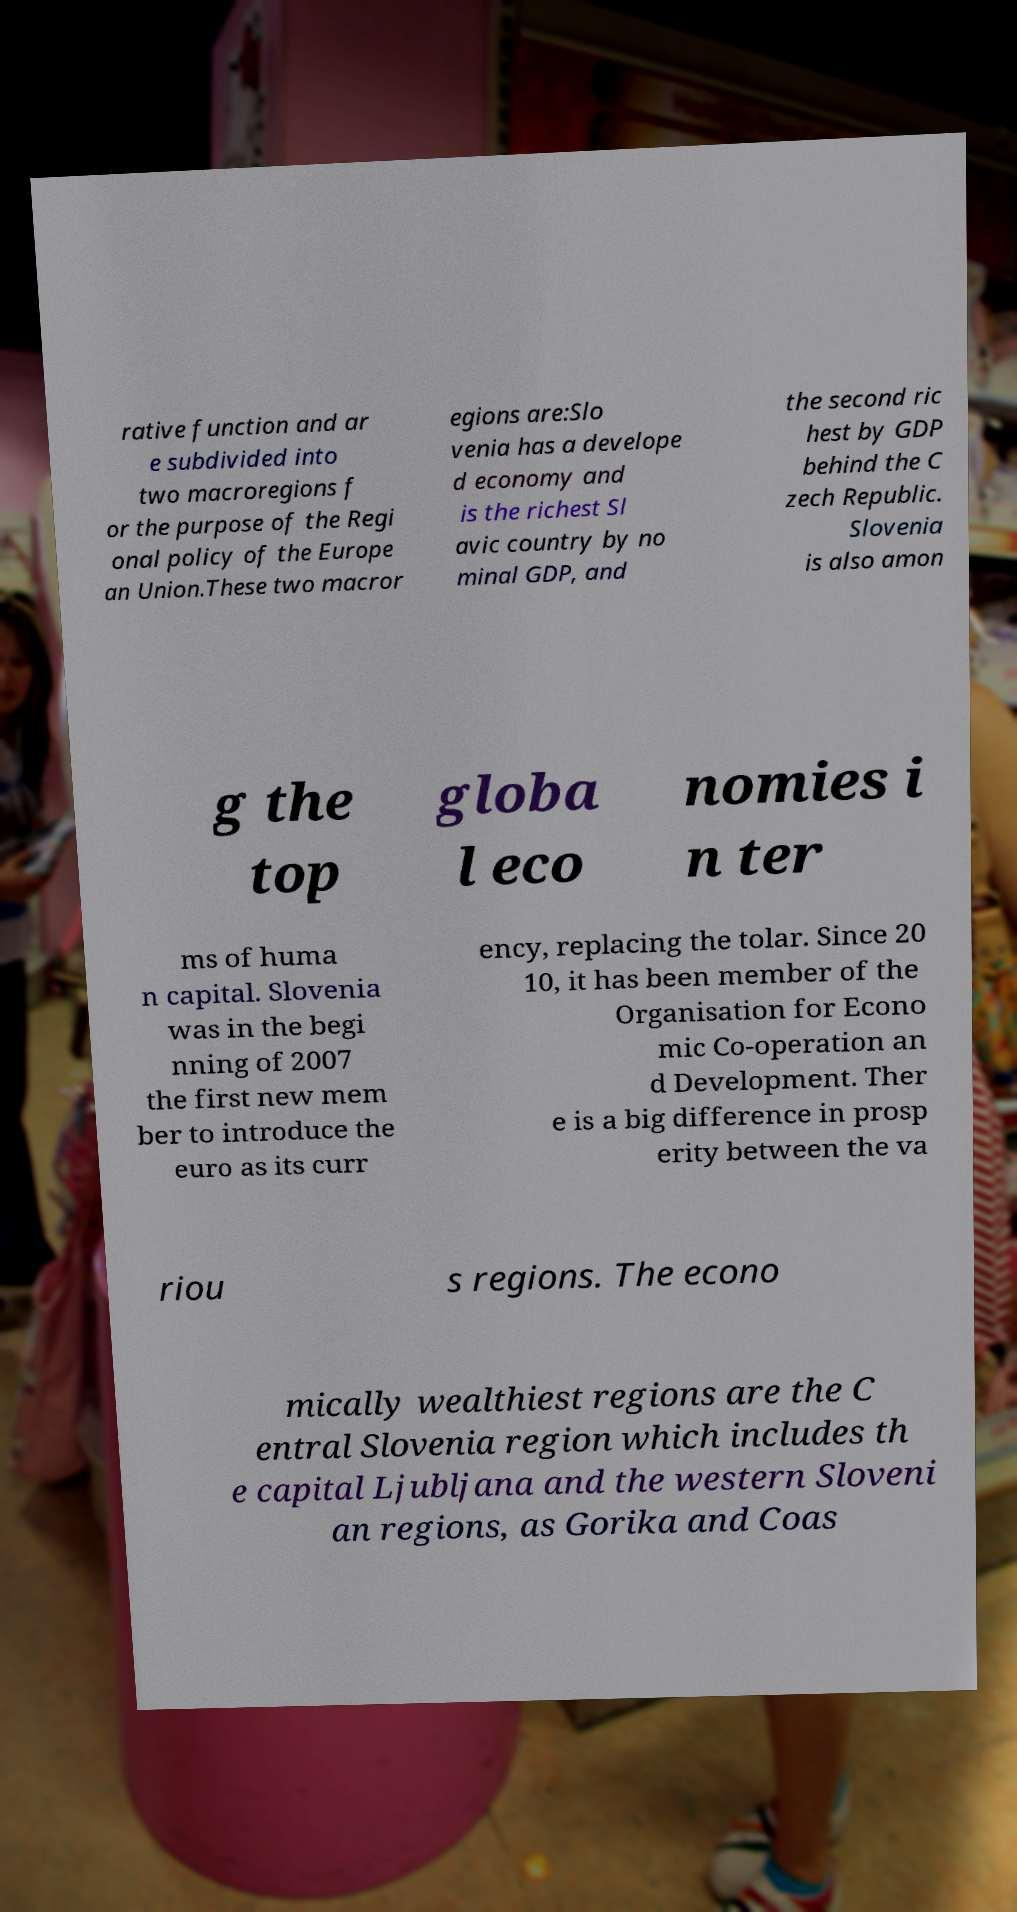Could you extract and type out the text from this image? rative function and ar e subdivided into two macroregions f or the purpose of the Regi onal policy of the Europe an Union.These two macror egions are:Slo venia has a develope d economy and is the richest Sl avic country by no minal GDP, and the second ric hest by GDP behind the C zech Republic. Slovenia is also amon g the top globa l eco nomies i n ter ms of huma n capital. Slovenia was in the begi nning of 2007 the first new mem ber to introduce the euro as its curr ency, replacing the tolar. Since 20 10, it has been member of the Organisation for Econo mic Co-operation an d Development. Ther e is a big difference in prosp erity between the va riou s regions. The econo mically wealthiest regions are the C entral Slovenia region which includes th e capital Ljubljana and the western Sloveni an regions, as Gorika and Coas 